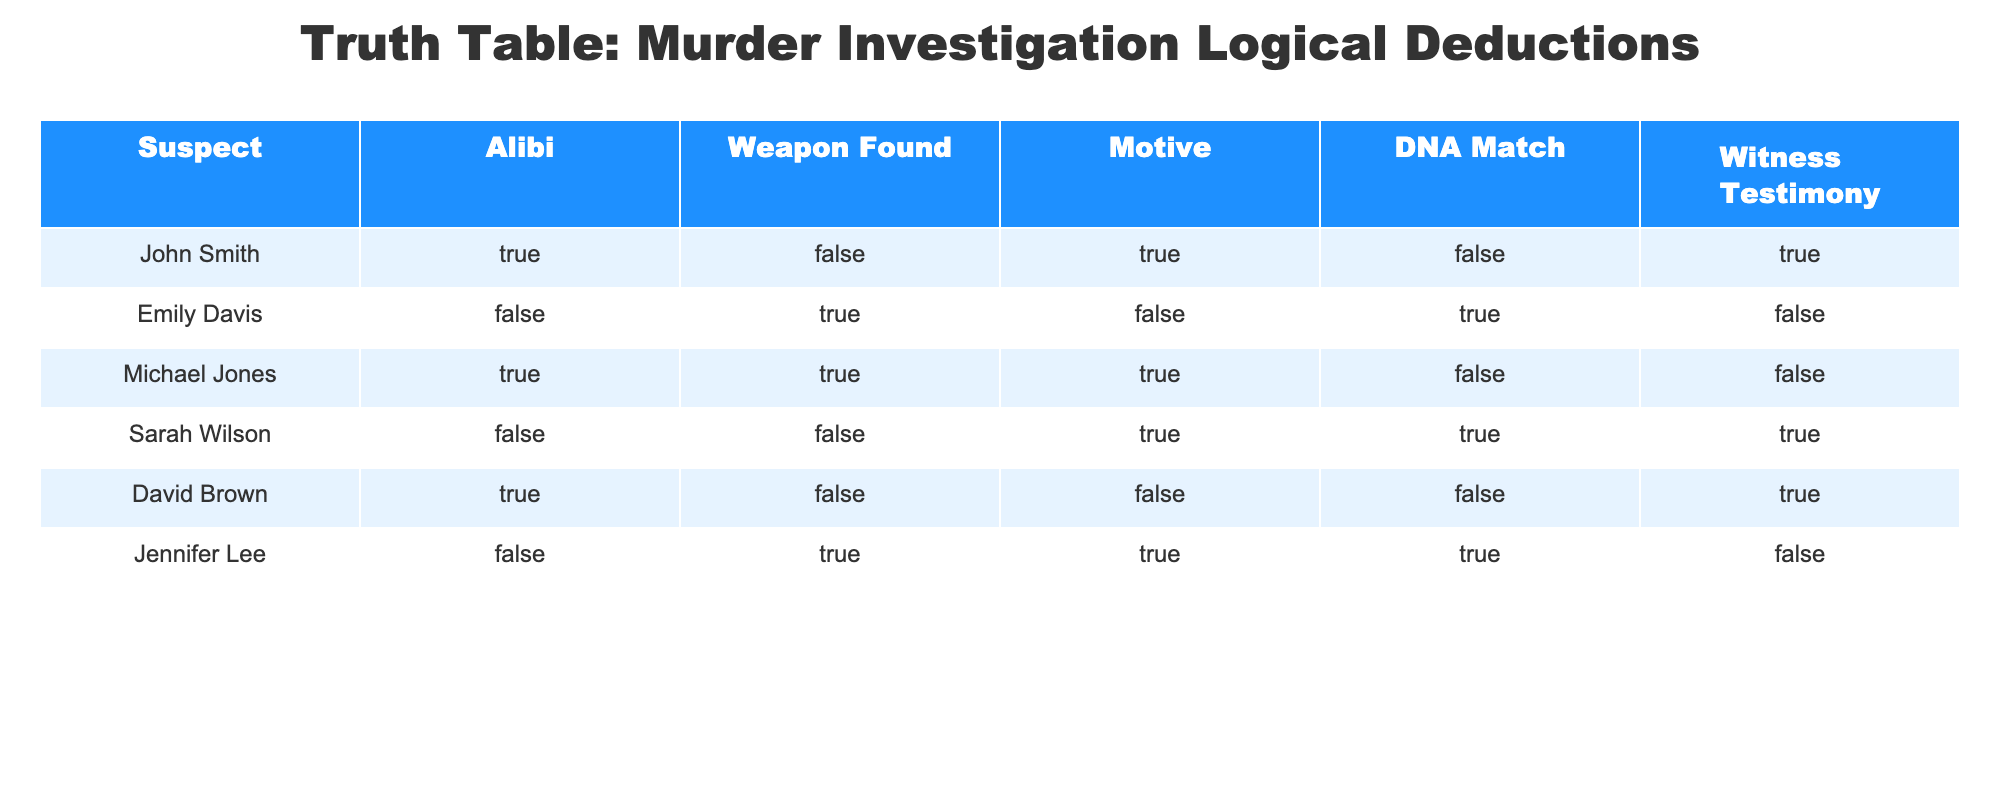What does Sarah Wilson's alibi status indicate? Sarah Wilson has a "FALSE" alibi, which means she does not have an established alibi during the time of the murder, making her a potential suspect.
Answer: FALSE How many suspects have a DNA match? In the table, there are two suspects with a DNA match: Emily Davis and Jennifer Lee. Thus, the count is 2.
Answer: 2 Is there a suspect with both a motive and a weapon found? Yes, Michael Jones has both a motive (TRUE) and a weapon found (TRUE). This raises suspicion regarding his involvement.
Answer: Yes Which suspect has no alibi and was found with a weapon? Emily Davis has no alibi (FALSE) and a weapon found (TRUE), indicating strong evidence against her.
Answer: Emily Davis What is the total number of suspects who have a motive? By filtering through the table: John Smith, Michael Jones, Sarah Wilson, and Jennifer Lee all have TRUE motives. That makes a total of 4 suspects.
Answer: 4 If a suspect has a DNA match and no alibi, does that indicate problematic implications for them? Yes, specifically, Emily Davis has a DNA match (TRUE) but no alibi (FALSE). This combination could imply strong evidence against her in the investigation.
Answer: Yes How many suspects have confirmed witness testimony? The suspects with witness testimony are John Smith, David Brown, and Sarah Wilson, totaling three suspects who have confirmed witness accounts.
Answer: 3 What can be inferred about Jennifer Lee's involvement in the case considering her factors? Jennifer Lee has a motive (TRUE), a DNA match (TRUE), but no alibi (FALSE) and no confirmed witness testimony (FALSE). Together, these indicate a potentially significant suspicion regarding her involvement in the murder.
Answer: Significant suspicion 